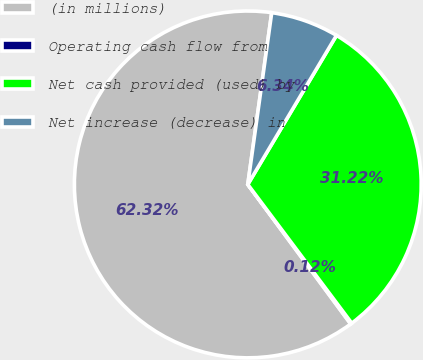Convert chart to OTSL. <chart><loc_0><loc_0><loc_500><loc_500><pie_chart><fcel>(in millions)<fcel>Operating cash flow from<fcel>Net cash provided (used) by<fcel>Net increase (decrease) in<nl><fcel>62.31%<fcel>0.12%<fcel>31.22%<fcel>6.34%<nl></chart> 